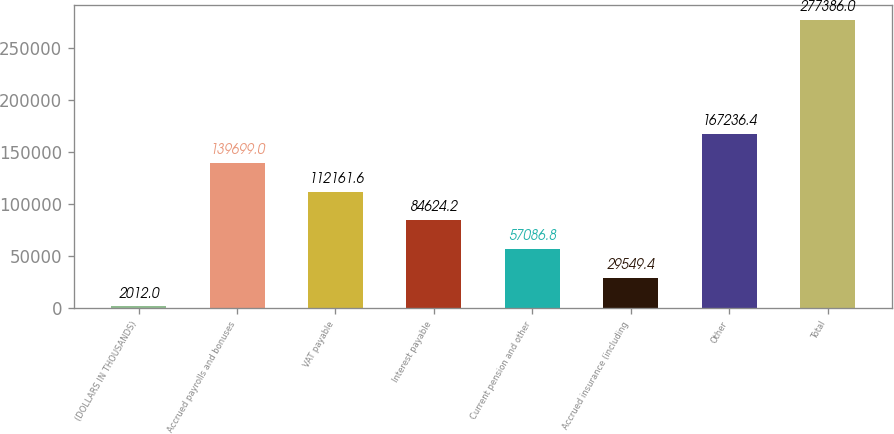Convert chart to OTSL. <chart><loc_0><loc_0><loc_500><loc_500><bar_chart><fcel>(DOLLARS IN THOUSANDS)<fcel>Accrued payrolls and bonuses<fcel>VAT payable<fcel>Interest payable<fcel>Current pension and other<fcel>Accrued insurance (including<fcel>Other<fcel>Total<nl><fcel>2012<fcel>139699<fcel>112162<fcel>84624.2<fcel>57086.8<fcel>29549.4<fcel>167236<fcel>277386<nl></chart> 